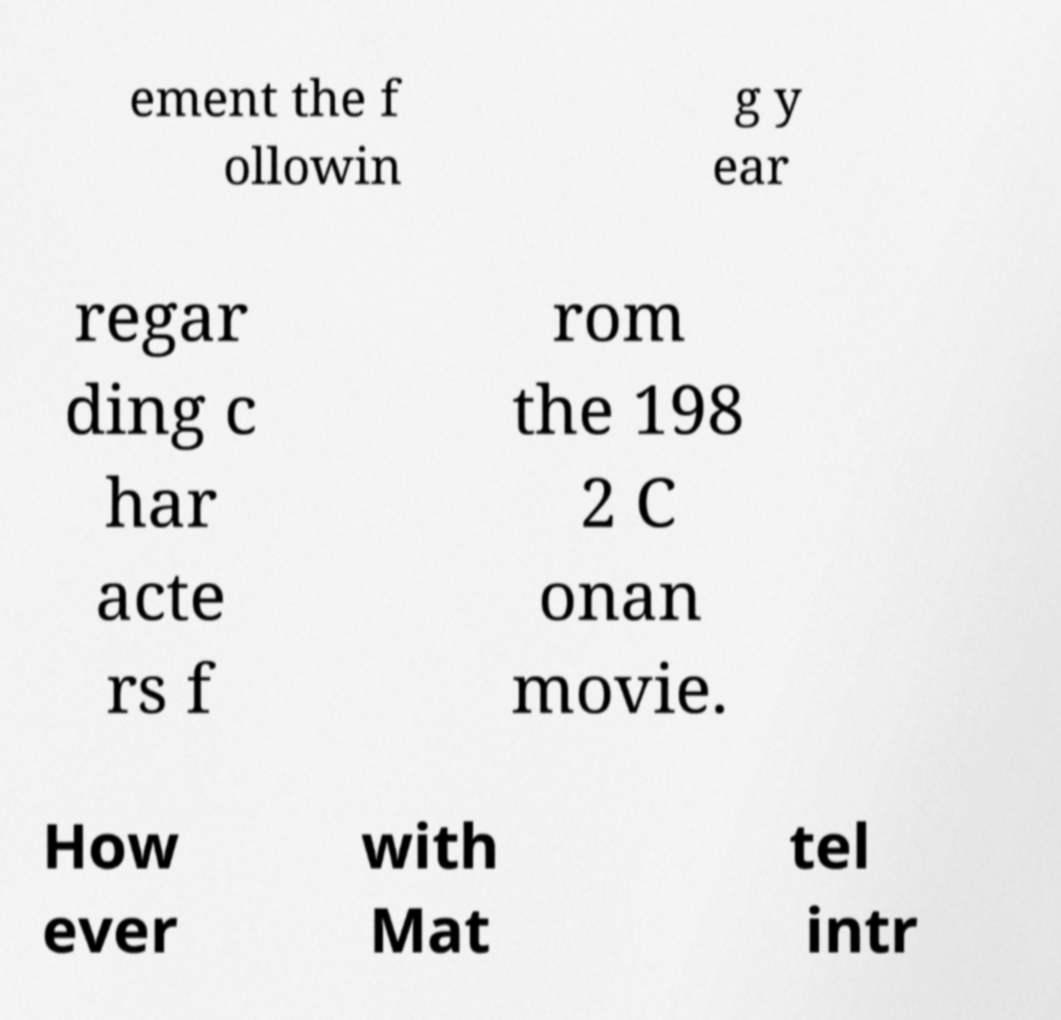For documentation purposes, I need the text within this image transcribed. Could you provide that? ement the f ollowin g y ear regar ding c har acte rs f rom the 198 2 C onan movie. How ever with Mat tel intr 